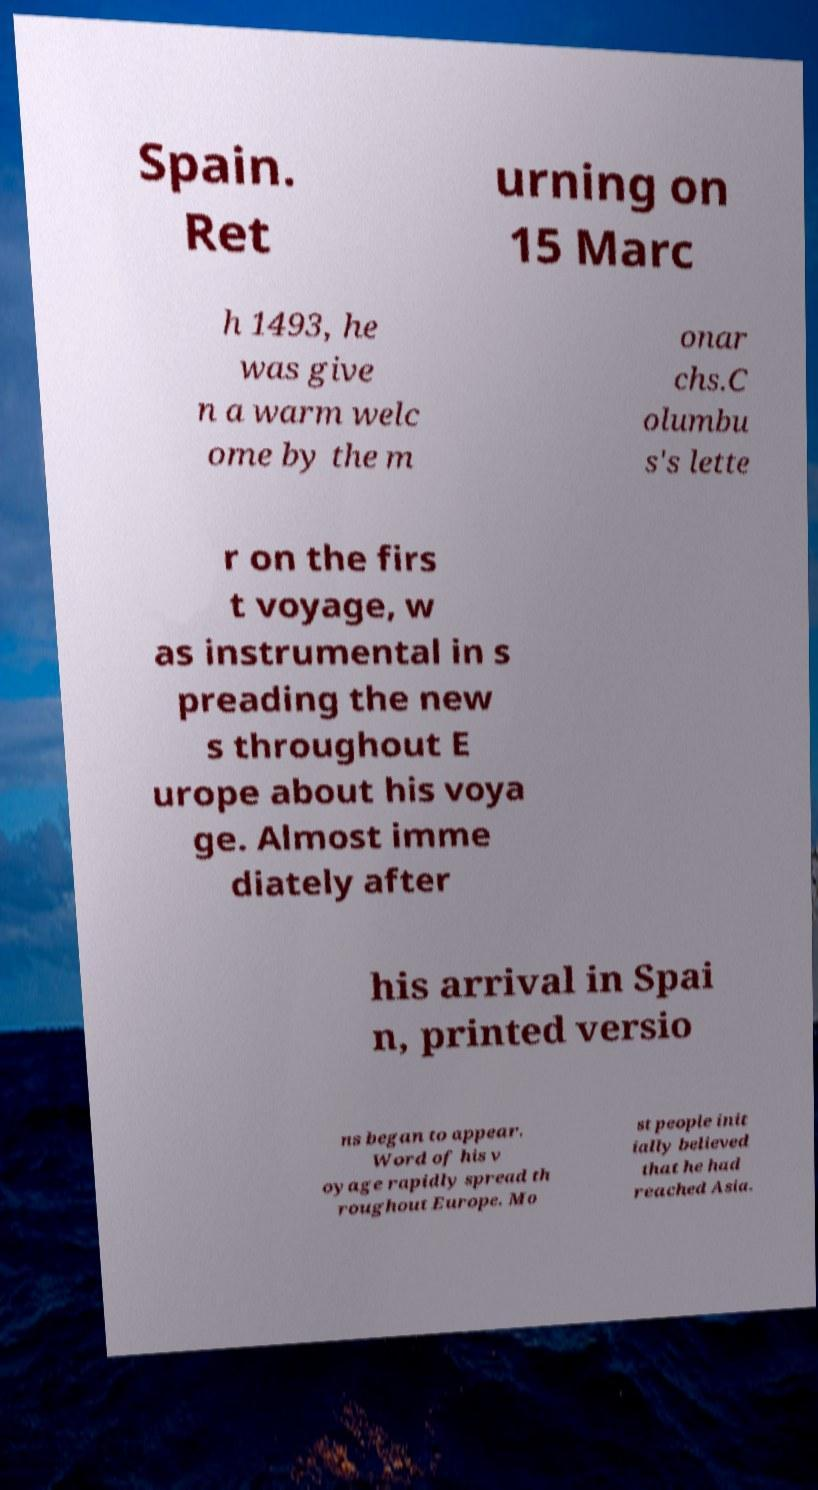What messages or text are displayed in this image? I need them in a readable, typed format. Spain. Ret urning on 15 Marc h 1493, he was give n a warm welc ome by the m onar chs.C olumbu s's lette r on the firs t voyage, w as instrumental in s preading the new s throughout E urope about his voya ge. Almost imme diately after his arrival in Spai n, printed versio ns began to appear. Word of his v oyage rapidly spread th roughout Europe. Mo st people init ially believed that he had reached Asia. 